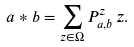Convert formula to latex. <formula><loc_0><loc_0><loc_500><loc_500>a * b = \sum _ { z \in \Omega } P _ { a , b } ^ { z } \, z .</formula> 